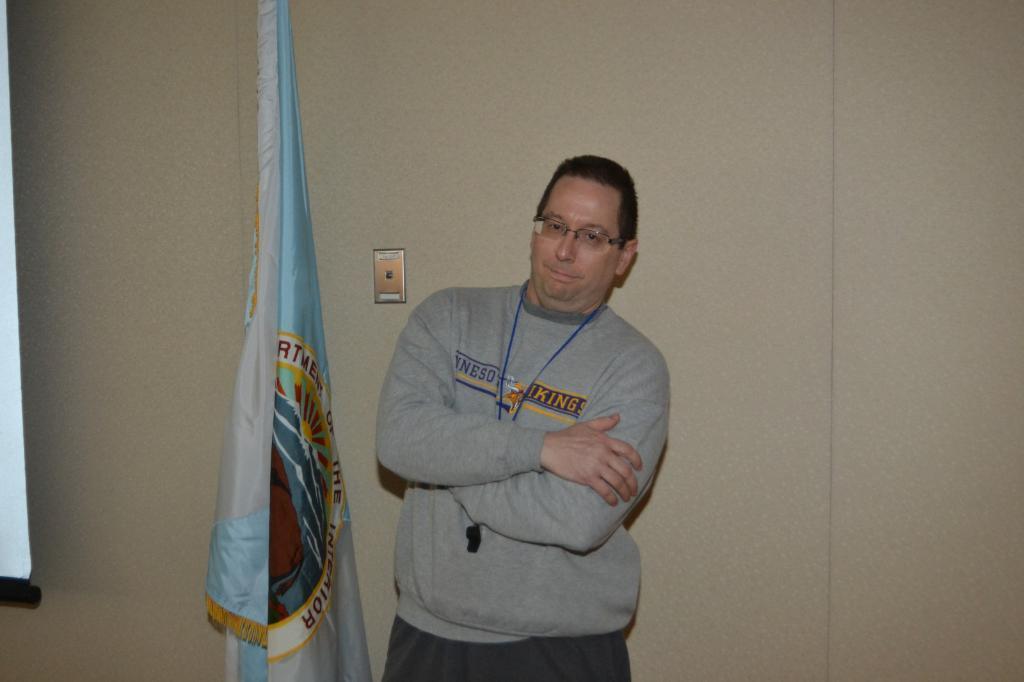Please provide a concise description of this image. As we can see in the image, there is a man standing. He is wearing spectacles. Beside the man there is a flag and behind the man there is cream color wall. 